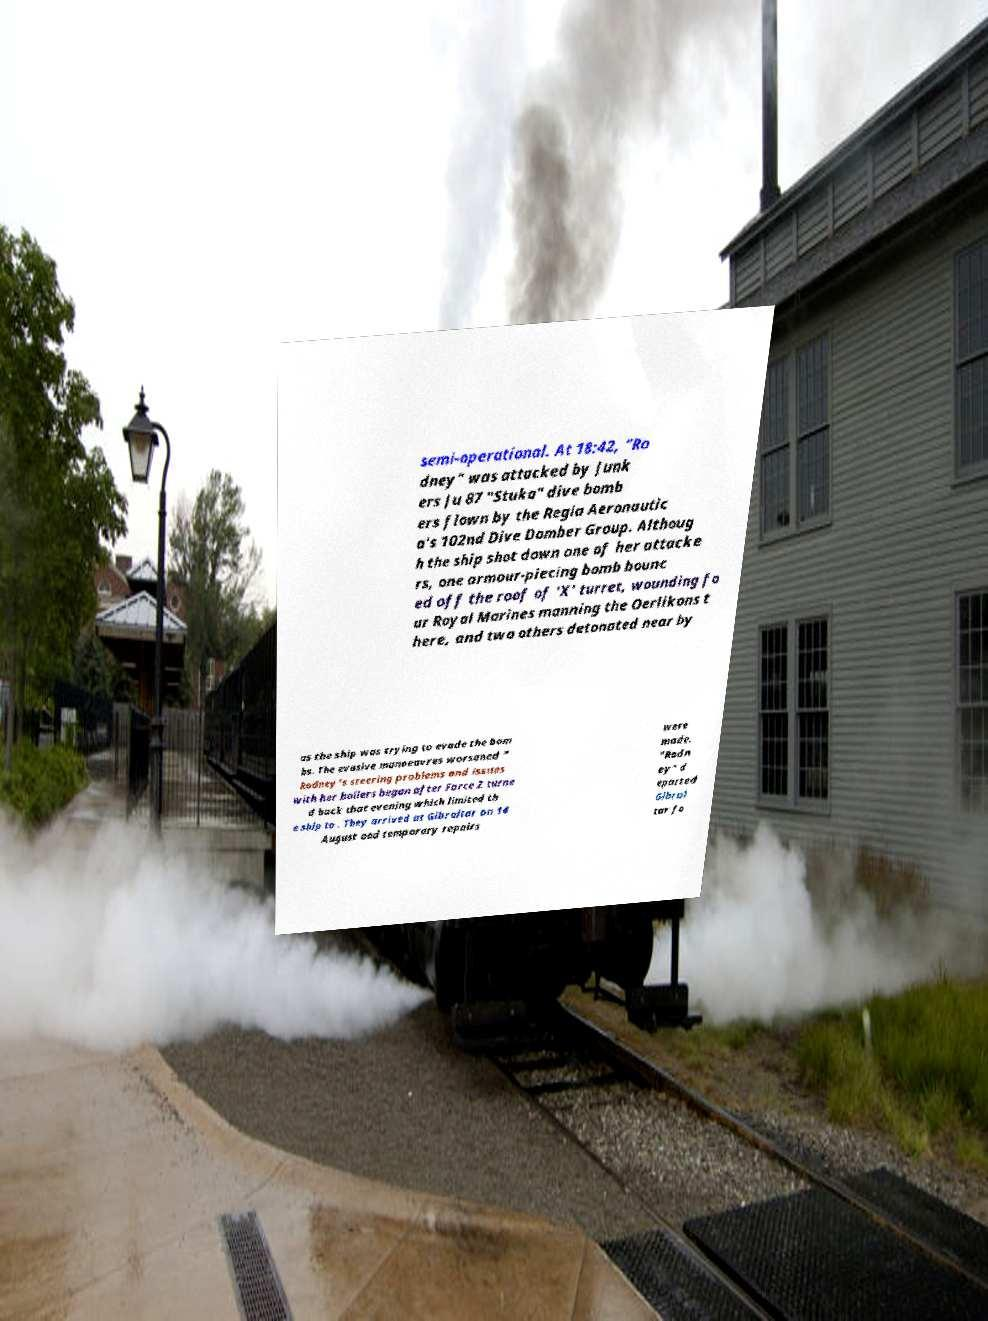Can you read and provide the text displayed in the image?This photo seems to have some interesting text. Can you extract and type it out for me? semi-operational. At 18:42, "Ro dney" was attacked by Junk ers Ju 87 "Stuka" dive bomb ers flown by the Regia Aeronautic a's 102nd Dive Domber Group. Althoug h the ship shot down one of her attacke rs, one armour-piecing bomb bounc ed off the roof of 'X' turret, wounding fo ur Royal Marines manning the Oerlikons t here, and two others detonated near by as the ship was trying to evade the bom bs. The evasive manoeuvres worsened " Rodney"s steering problems and issues with her boilers began after Force Z turne d back that evening which limited th e ship to . They arrived at Gibraltar on 14 August and temporary repairs were made. "Rodn ey" d eparted Gibral tar fo 